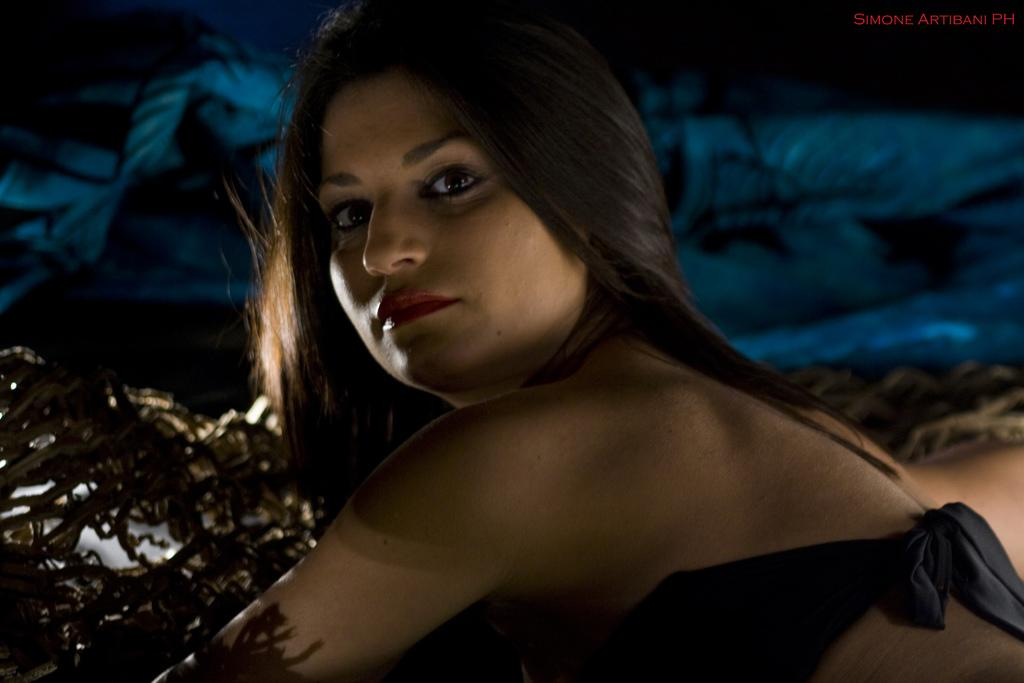What is the main subject of the image? There is a person in the image. Can you describe the object near the person? Unfortunately, the facts provided do not give any details about the object near the person. What can be observed about the background of the image? The background of the image is blurry. What type of substance is being used by the person in the image? There is no information about any substance being used by the person in the image. Can you tell me how many wristwatches are visible in the image? There is no mention of wristwatches in the provided facts, so we cannot answer this question. 